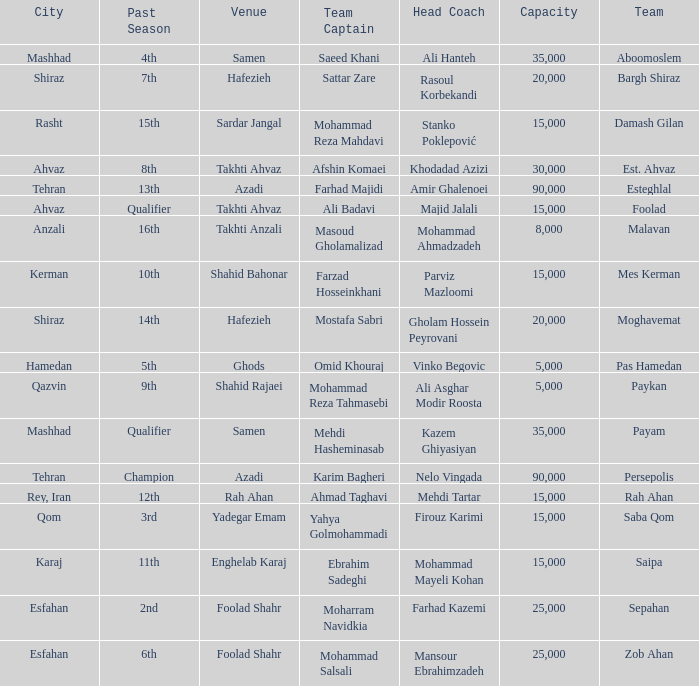What is the Capacity of the Venue of Head Coach Farhad Kazemi? 25000.0. 